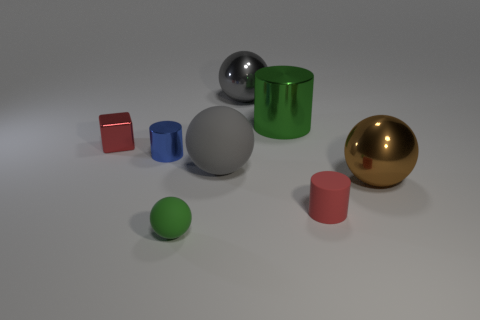Subtract all small cylinders. How many cylinders are left? 1 Subtract all green balls. How many balls are left? 3 Subtract all gray cylinders. How many gray balls are left? 2 Add 2 brown things. How many objects exist? 10 Subtract all cylinders. How many objects are left? 5 Subtract 1 cylinders. How many cylinders are left? 2 Add 7 big gray rubber spheres. How many big gray rubber spheres exist? 8 Subtract 0 blue blocks. How many objects are left? 8 Subtract all blue cylinders. Subtract all purple cubes. How many cylinders are left? 2 Subtract all yellow metal blocks. Subtract all gray metal spheres. How many objects are left? 7 